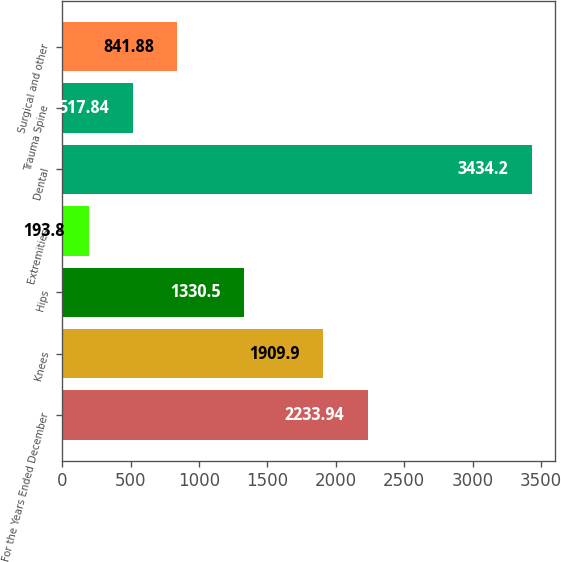Convert chart. <chart><loc_0><loc_0><loc_500><loc_500><bar_chart><fcel>For the Years Ended December<fcel>Knees<fcel>Hips<fcel>Extremities<fcel>Dental<fcel>Trauma Spine<fcel>Surgical and other<nl><fcel>2233.94<fcel>1909.9<fcel>1330.5<fcel>193.8<fcel>3434.2<fcel>517.84<fcel>841.88<nl></chart> 